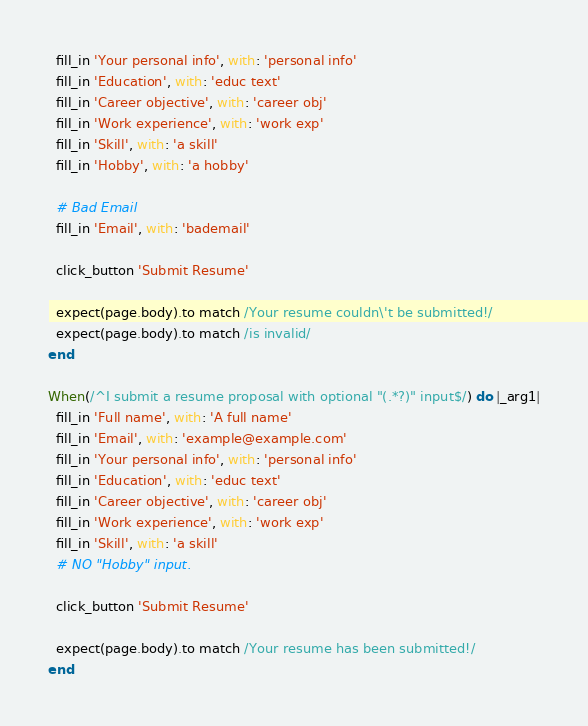<code> <loc_0><loc_0><loc_500><loc_500><_Ruby_>  fill_in 'Your personal info', with: 'personal info'
  fill_in 'Education', with: 'educ text'
  fill_in 'Career objective', with: 'career obj'
  fill_in 'Work experience', with: 'work exp'
  fill_in 'Skill', with: 'a skill'
  fill_in 'Hobby', with: 'a hobby'

  # Bad Email
  fill_in 'Email', with: 'bademail'

  click_button 'Submit Resume'

  expect(page.body).to match /Your resume couldn\'t be submitted!/
  expect(page.body).to match /is invalid/
end

When(/^I submit a resume proposal with optional "(.*?)" input$/) do |_arg1|
  fill_in 'Full name', with: 'A full name'
  fill_in 'Email', with: 'example@example.com'
  fill_in 'Your personal info', with: 'personal info'
  fill_in 'Education', with: 'educ text'
  fill_in 'Career objective', with: 'career obj'
  fill_in 'Work experience', with: 'work exp'
  fill_in 'Skill', with: 'a skill'
  # NO "Hobby" input.

  click_button 'Submit Resume'

  expect(page.body).to match /Your resume has been submitted!/
end
</code> 